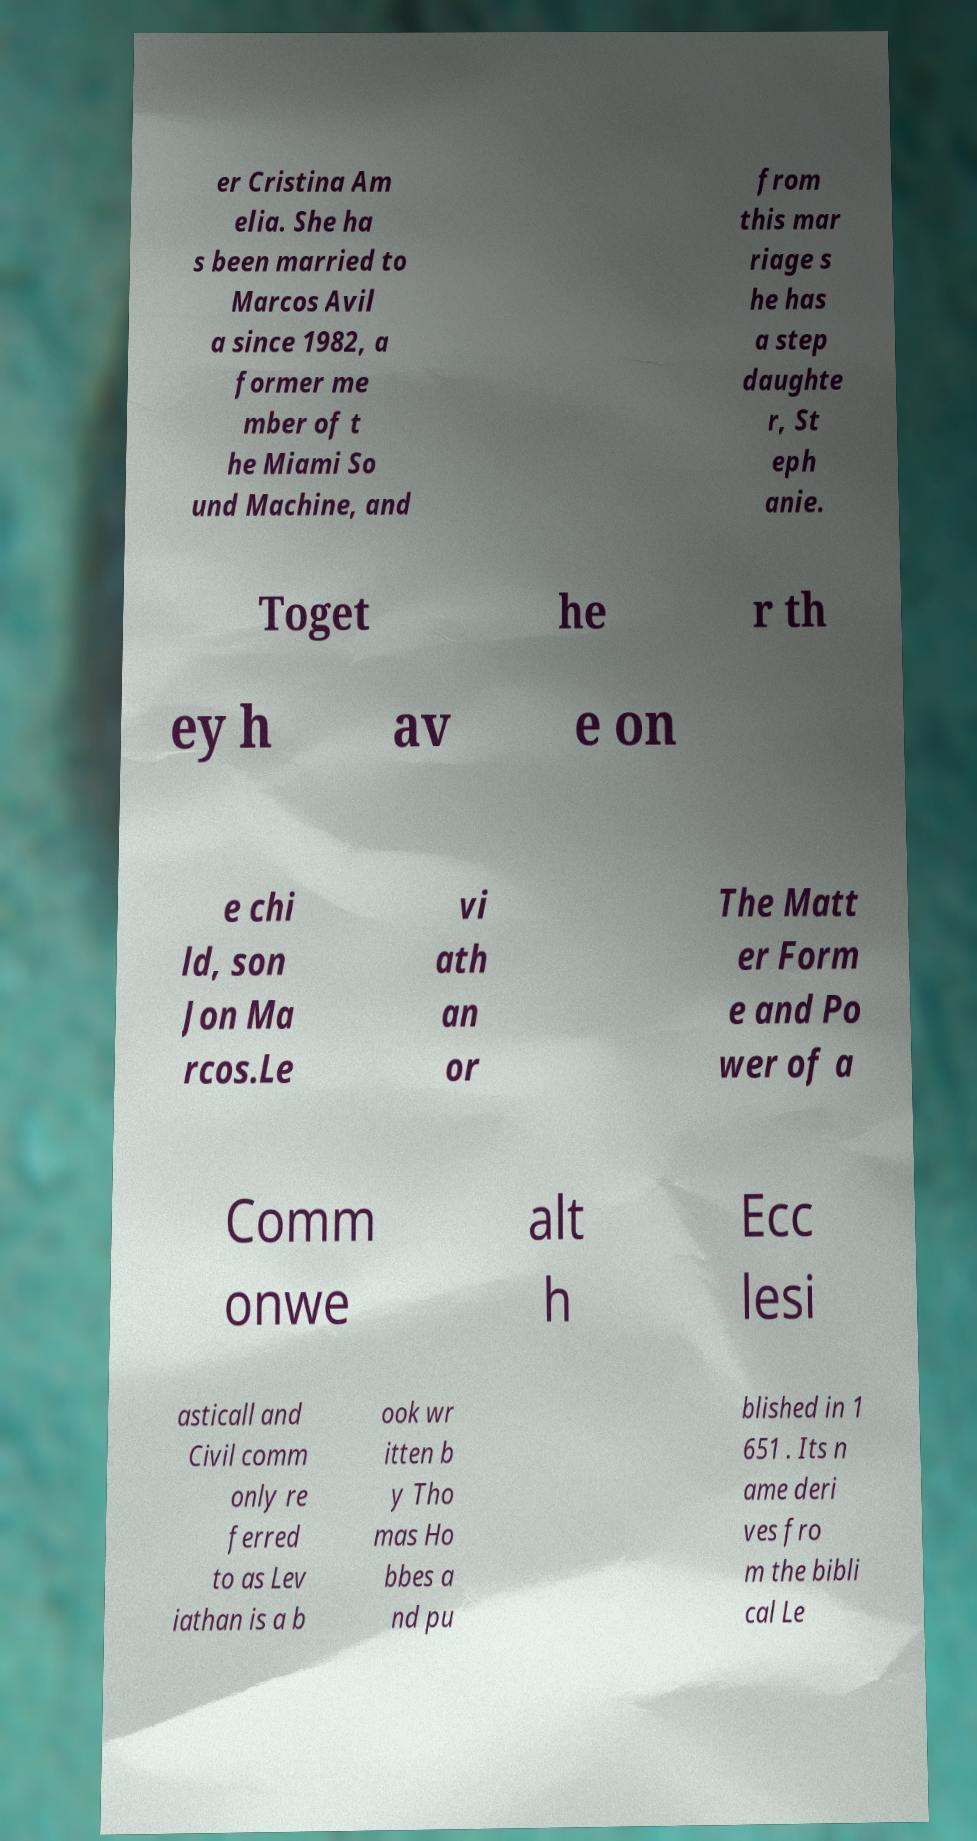Please read and relay the text visible in this image. What does it say? er Cristina Am elia. She ha s been married to Marcos Avil a since 1982, a former me mber of t he Miami So und Machine, and from this mar riage s he has a step daughte r, St eph anie. Toget he r th ey h av e on e chi ld, son Jon Ma rcos.Le vi ath an or The Matt er Form e and Po wer of a Comm onwe alt h Ecc lesi asticall and Civil comm only re ferred to as Lev iathan is a b ook wr itten b y Tho mas Ho bbes a nd pu blished in 1 651 . Its n ame deri ves fro m the bibli cal Le 